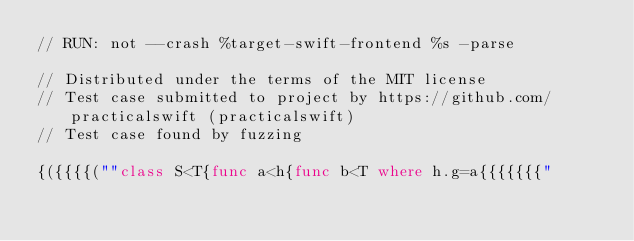Convert code to text. <code><loc_0><loc_0><loc_500><loc_500><_Swift_>// RUN: not --crash %target-swift-frontend %s -parse

// Distributed under the terms of the MIT license
// Test case submitted to project by https://github.com/practicalswift (practicalswift)
// Test case found by fuzzing

{({{{{(""class S<T{func a<h{func b<T where h.g=a{{{{{{{"
</code> 